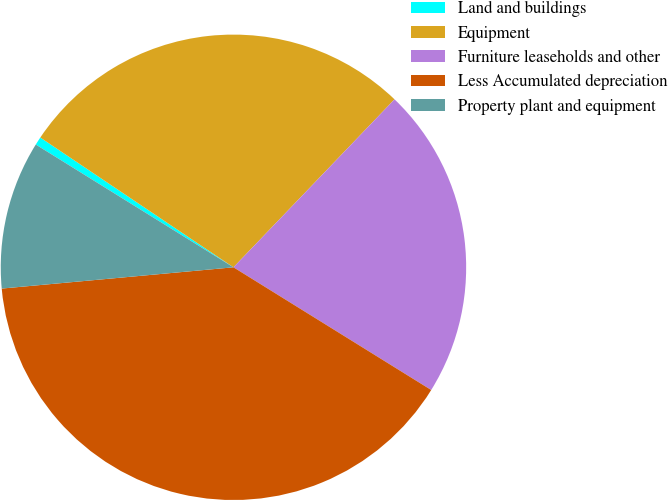Convert chart to OTSL. <chart><loc_0><loc_0><loc_500><loc_500><pie_chart><fcel>Land and buildings<fcel>Equipment<fcel>Furniture leaseholds and other<fcel>Less Accumulated depreciation<fcel>Property plant and equipment<nl><fcel>0.57%<fcel>27.75%<fcel>21.67%<fcel>39.7%<fcel>10.3%<nl></chart> 